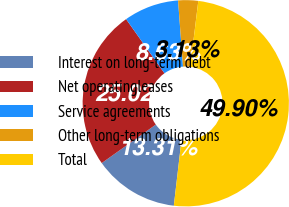Convert chart. <chart><loc_0><loc_0><loc_500><loc_500><pie_chart><fcel>Interest on long-term debt<fcel>Net operatingleases<fcel>Service agreements<fcel>Other long-term obligations<fcel>Total<nl><fcel>13.31%<fcel>25.02%<fcel>8.63%<fcel>3.13%<fcel>49.9%<nl></chart> 